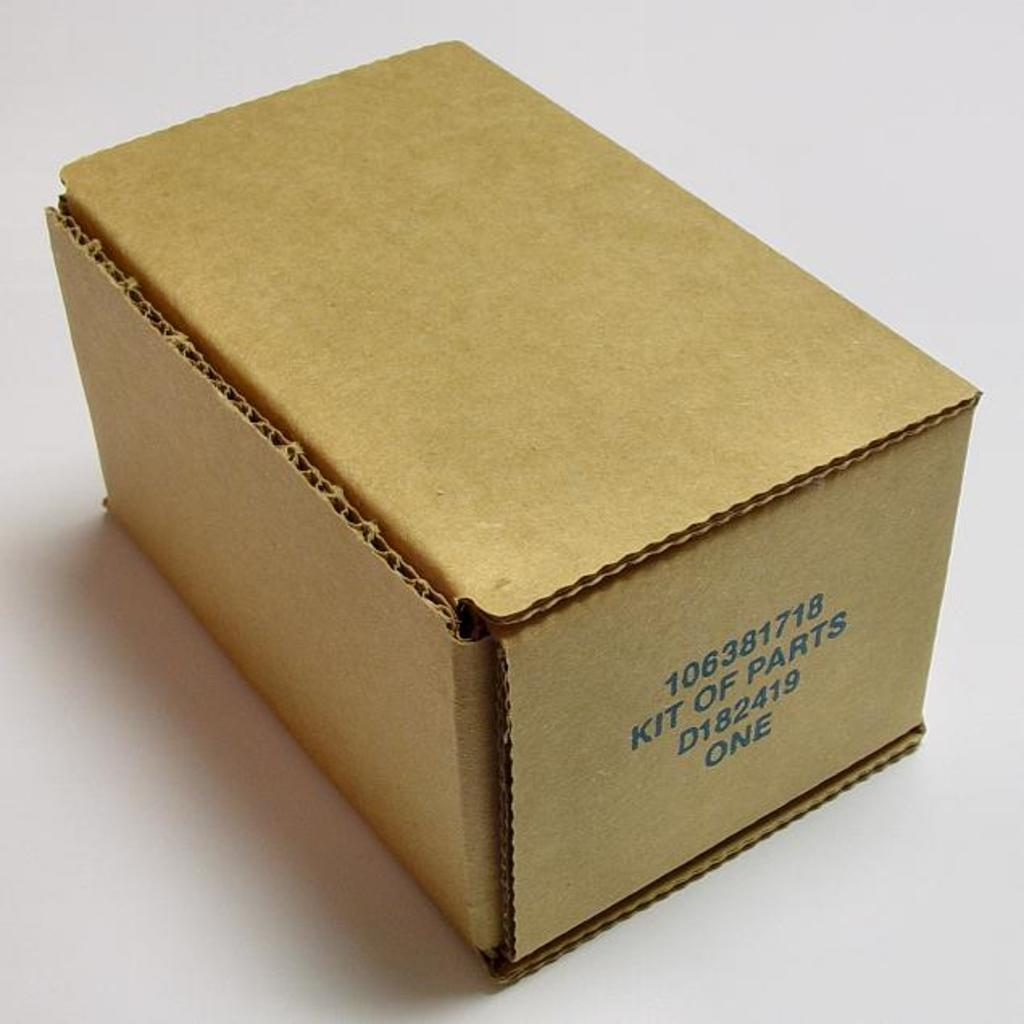<image>
Relay a brief, clear account of the picture shown. A cardboard box has the words “kit of parts” on the side. 